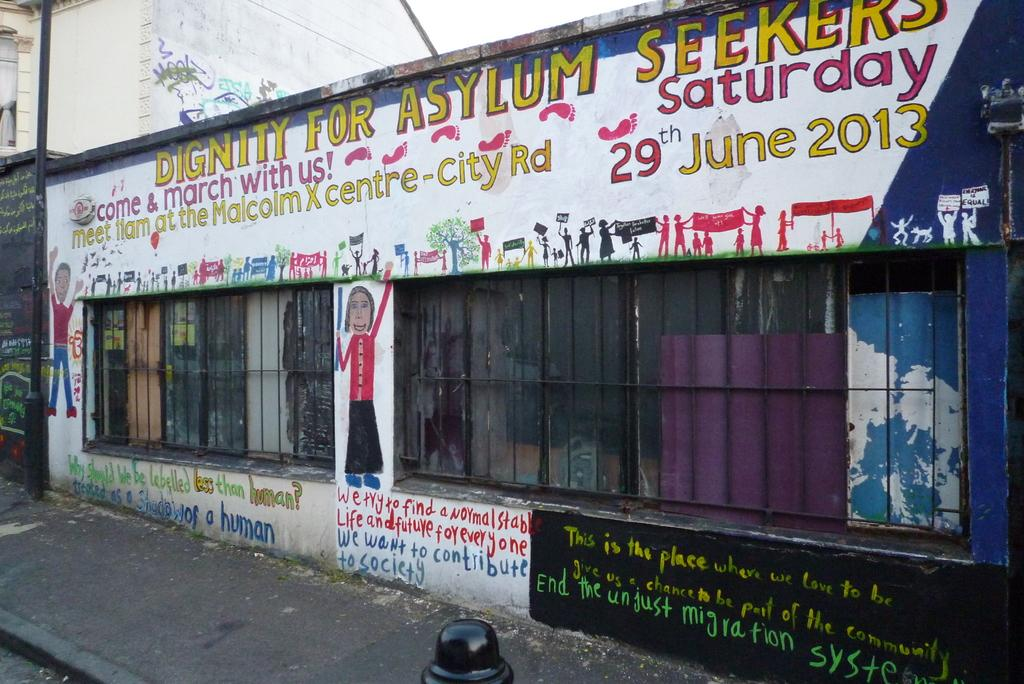What type of structures can be seen in the image? There are buildings in the image. What is written or displayed on a wall in the image? There is text on a wall in the image. What type of artwork is present on the wall in the image? There are paintings on the wall in the image. What type of surface is visible underfoot in the image? The pavement is visible in the image. What object is located to the side in the image? There is a pole to the side in the image. How many boys are attending the meeting in the image? There is no meeting or boys present in the image. Who is the secretary in the image? There is no secretary present in the image. 